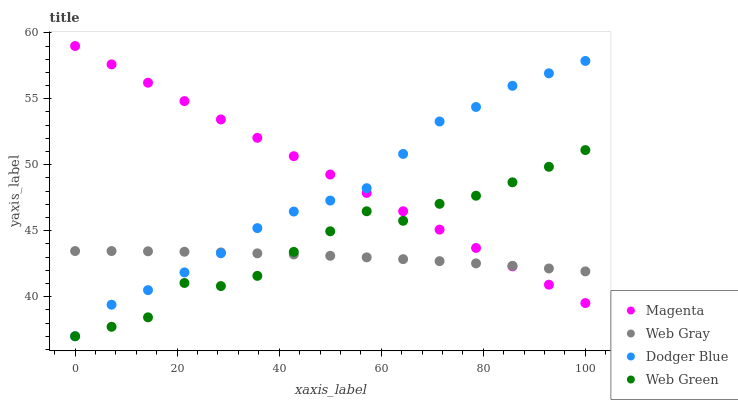Does Web Gray have the minimum area under the curve?
Answer yes or no. Yes. Does Magenta have the maximum area under the curve?
Answer yes or no. Yes. Does Dodger Blue have the minimum area under the curve?
Answer yes or no. No. Does Dodger Blue have the maximum area under the curve?
Answer yes or no. No. Is Magenta the smoothest?
Answer yes or no. Yes. Is Web Green the roughest?
Answer yes or no. Yes. Is Web Gray the smoothest?
Answer yes or no. No. Is Web Gray the roughest?
Answer yes or no. No. Does Dodger Blue have the lowest value?
Answer yes or no. Yes. Does Web Gray have the lowest value?
Answer yes or no. No. Does Magenta have the highest value?
Answer yes or no. Yes. Does Dodger Blue have the highest value?
Answer yes or no. No. Does Web Green intersect Dodger Blue?
Answer yes or no. Yes. Is Web Green less than Dodger Blue?
Answer yes or no. No. Is Web Green greater than Dodger Blue?
Answer yes or no. No. 